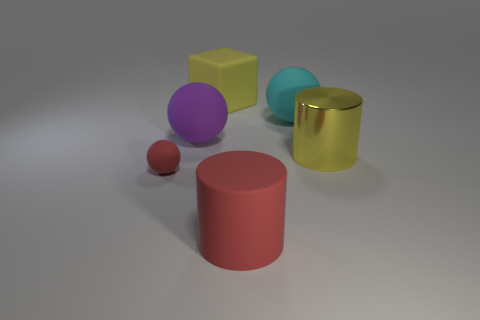Add 2 yellow blocks. How many objects exist? 8 Subtract all cubes. How many objects are left? 5 Add 2 large matte cylinders. How many large matte cylinders are left? 3 Add 2 tiny red blocks. How many tiny red blocks exist? 2 Subtract 0 brown cylinders. How many objects are left? 6 Subtract all large blocks. Subtract all spheres. How many objects are left? 2 